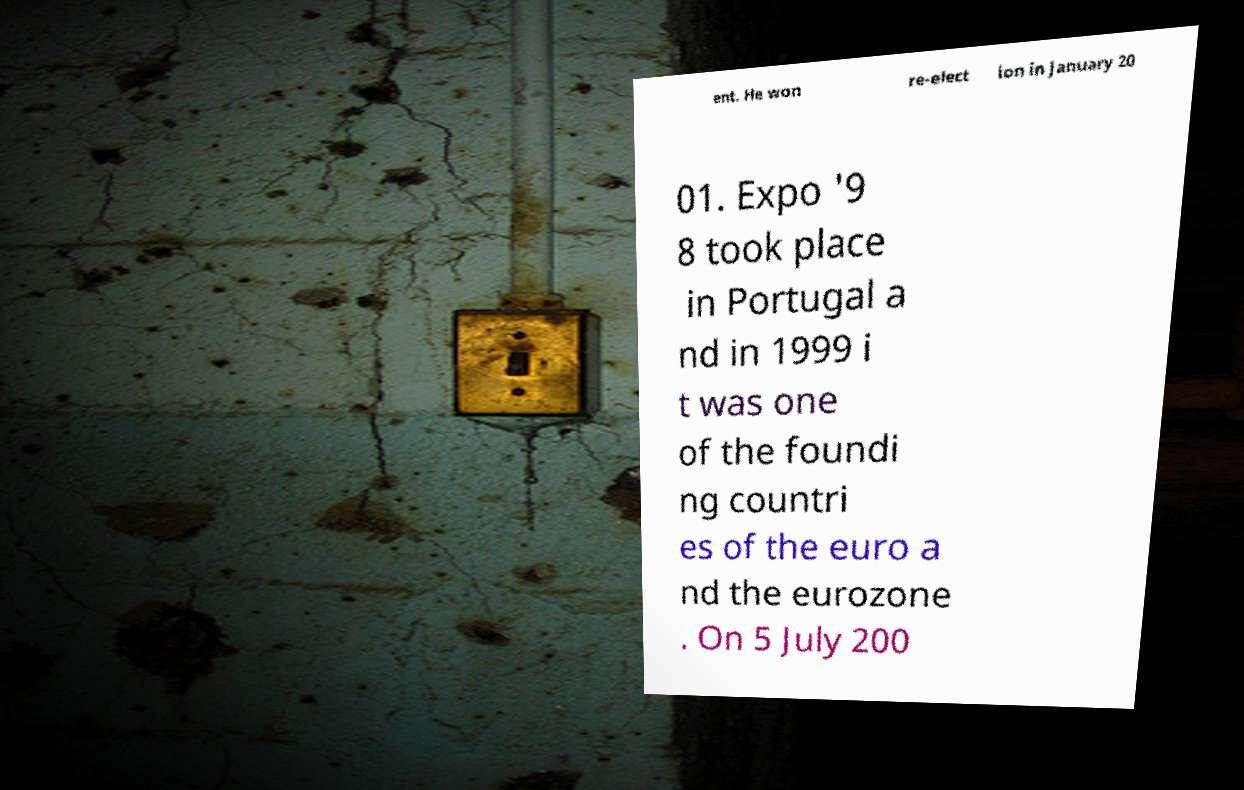Please read and relay the text visible in this image. What does it say? ent. He won re-elect ion in January 20 01. Expo '9 8 took place in Portugal a nd in 1999 i t was one of the foundi ng countri es of the euro a nd the eurozone . On 5 July 200 